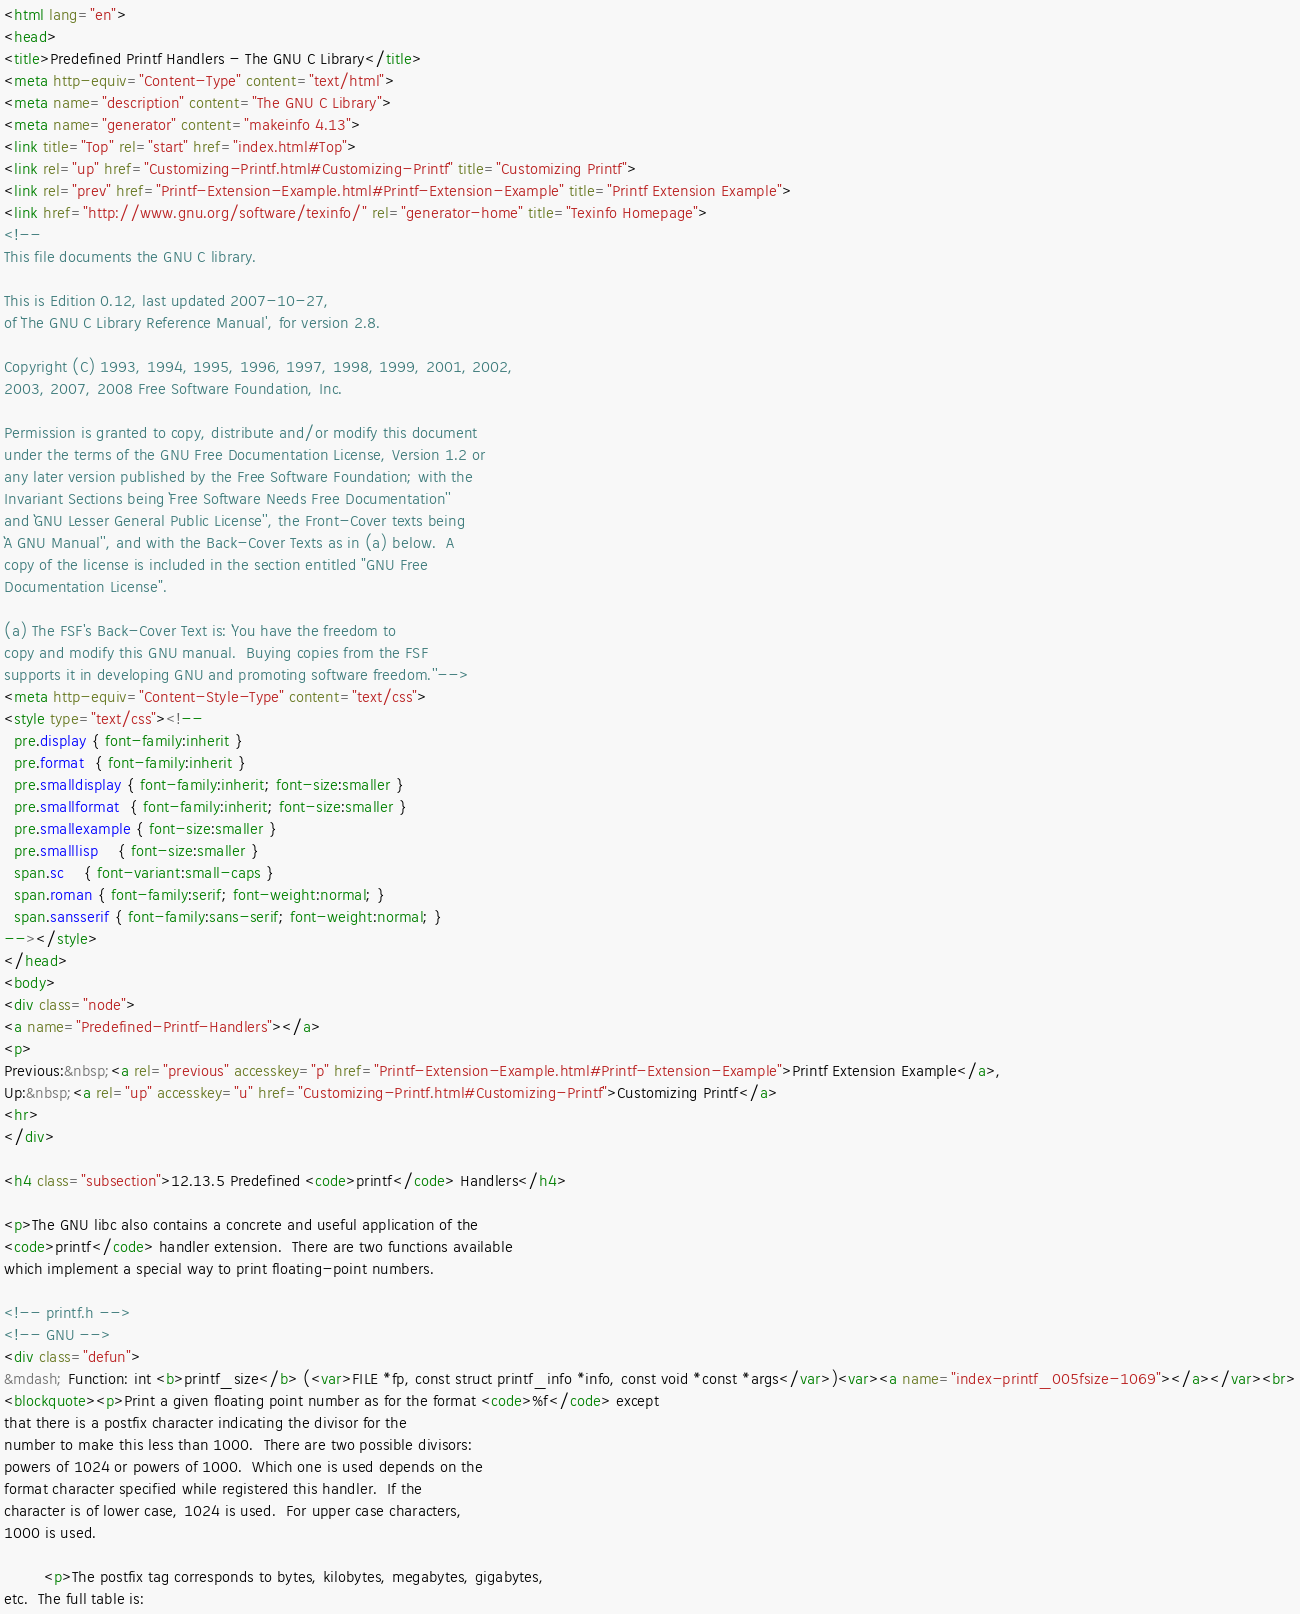<code> <loc_0><loc_0><loc_500><loc_500><_HTML_><html lang="en">
<head>
<title>Predefined Printf Handlers - The GNU C Library</title>
<meta http-equiv="Content-Type" content="text/html">
<meta name="description" content="The GNU C Library">
<meta name="generator" content="makeinfo 4.13">
<link title="Top" rel="start" href="index.html#Top">
<link rel="up" href="Customizing-Printf.html#Customizing-Printf" title="Customizing Printf">
<link rel="prev" href="Printf-Extension-Example.html#Printf-Extension-Example" title="Printf Extension Example">
<link href="http://www.gnu.org/software/texinfo/" rel="generator-home" title="Texinfo Homepage">
<!--
This file documents the GNU C library.

This is Edition 0.12, last updated 2007-10-27,
of `The GNU C Library Reference Manual', for version 2.8.

Copyright (C) 1993, 1994, 1995, 1996, 1997, 1998, 1999, 2001, 2002,
2003, 2007, 2008 Free Software Foundation, Inc.

Permission is granted to copy, distribute and/or modify this document
under the terms of the GNU Free Documentation License, Version 1.2 or
any later version published by the Free Software Foundation; with the
Invariant Sections being ``Free Software Needs Free Documentation''
and ``GNU Lesser General Public License'', the Front-Cover texts being
``A GNU Manual'', and with the Back-Cover Texts as in (a) below.  A
copy of the license is included in the section entitled "GNU Free
Documentation License".

(a) The FSF's Back-Cover Text is: ``You have the freedom to
copy and modify this GNU manual.  Buying copies from the FSF
supports it in developing GNU and promoting software freedom.''-->
<meta http-equiv="Content-Style-Type" content="text/css">
<style type="text/css"><!--
  pre.display { font-family:inherit }
  pre.format  { font-family:inherit }
  pre.smalldisplay { font-family:inherit; font-size:smaller }
  pre.smallformat  { font-family:inherit; font-size:smaller }
  pre.smallexample { font-size:smaller }
  pre.smalllisp    { font-size:smaller }
  span.sc    { font-variant:small-caps }
  span.roman { font-family:serif; font-weight:normal; } 
  span.sansserif { font-family:sans-serif; font-weight:normal; } 
--></style>
</head>
<body>
<div class="node">
<a name="Predefined-Printf-Handlers"></a>
<p>
Previous:&nbsp;<a rel="previous" accesskey="p" href="Printf-Extension-Example.html#Printf-Extension-Example">Printf Extension Example</a>,
Up:&nbsp;<a rel="up" accesskey="u" href="Customizing-Printf.html#Customizing-Printf">Customizing Printf</a>
<hr>
</div>

<h4 class="subsection">12.13.5 Predefined <code>printf</code> Handlers</h4>

<p>The GNU libc also contains a concrete and useful application of the
<code>printf</code> handler extension.  There are two functions available
which implement a special way to print floating-point numbers.

<!-- printf.h -->
<!-- GNU -->
<div class="defun">
&mdash; Function: int <b>printf_size</b> (<var>FILE *fp, const struct printf_info *info, const void *const *args</var>)<var><a name="index-printf_005fsize-1069"></a></var><br>
<blockquote><p>Print a given floating point number as for the format <code>%f</code> except
that there is a postfix character indicating the divisor for the
number to make this less than 1000.  There are two possible divisors:
powers of 1024 or powers of 1000.  Which one is used depends on the
format character specified while registered this handler.  If the
character is of lower case, 1024 is used.  For upper case characters,
1000 is used.

        <p>The postfix tag corresponds to bytes, kilobytes, megabytes, gigabytes,
etc.  The full table is:
</code> 